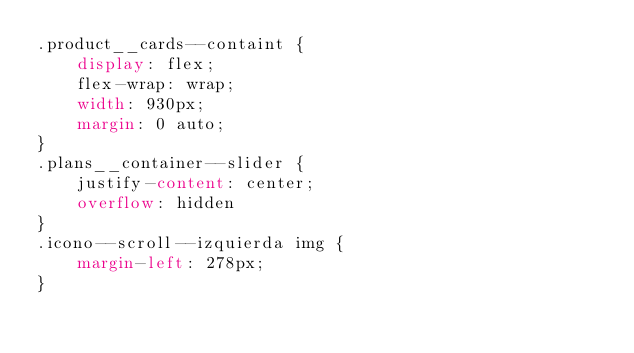Convert code to text. <code><loc_0><loc_0><loc_500><loc_500><_CSS_>.product__cards--containt {
    display: flex;
    flex-wrap: wrap;
    width: 930px;
    margin: 0 auto;
}
.plans__container--slider {
    justify-content: center;
    overflow: hidden
}
.icono--scroll--izquierda img {
    margin-left: 278px;
}



</code> 